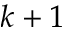<formula> <loc_0><loc_0><loc_500><loc_500>k + 1</formula> 